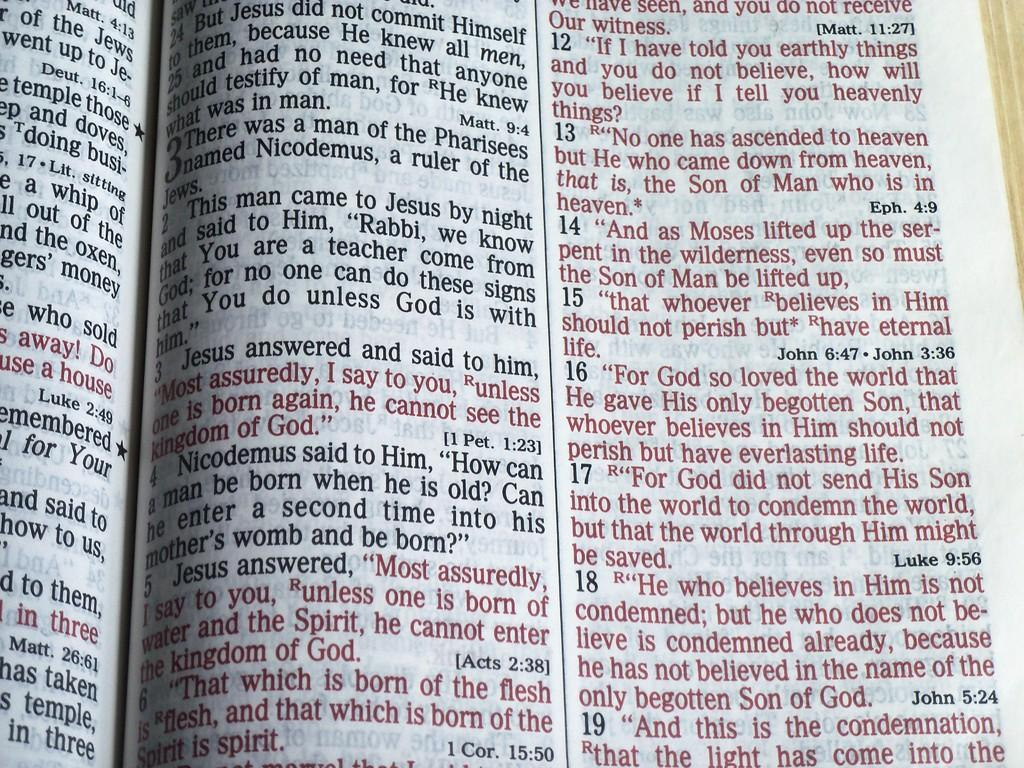Provide a one-sentence caption for the provided image. open bible and one of the passages starts with This man came to Jesus by night and said to Him. 